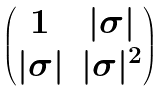<formula> <loc_0><loc_0><loc_500><loc_500>\begin{pmatrix} 1 & | \sigma | \\ | \sigma | & | \sigma | ^ { 2 } \end{pmatrix}</formula> 